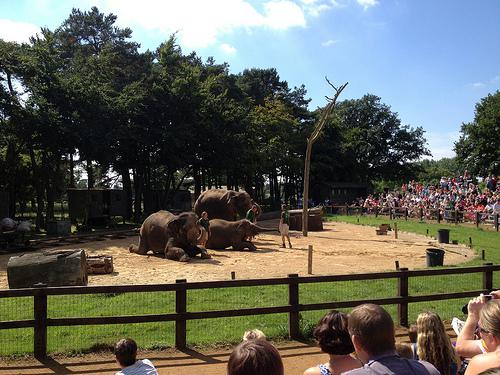Question: how are the animals confined?
Choices:
A. Barbed wire.
B. A ring of fire.
C. With a fence.
D. Rope.
Answer with the letter. Answer: C Question: what animals are here?
Choices:
A. Zebras.
B. Tigers.
C. Lions.
D. Elephants.
Answer with the letter. Answer: D Question: who is watching?
Choices:
A. Judges.
B. Recruiters.
C. Random people.
D. Spectators.
Answer with the letter. Answer: D 